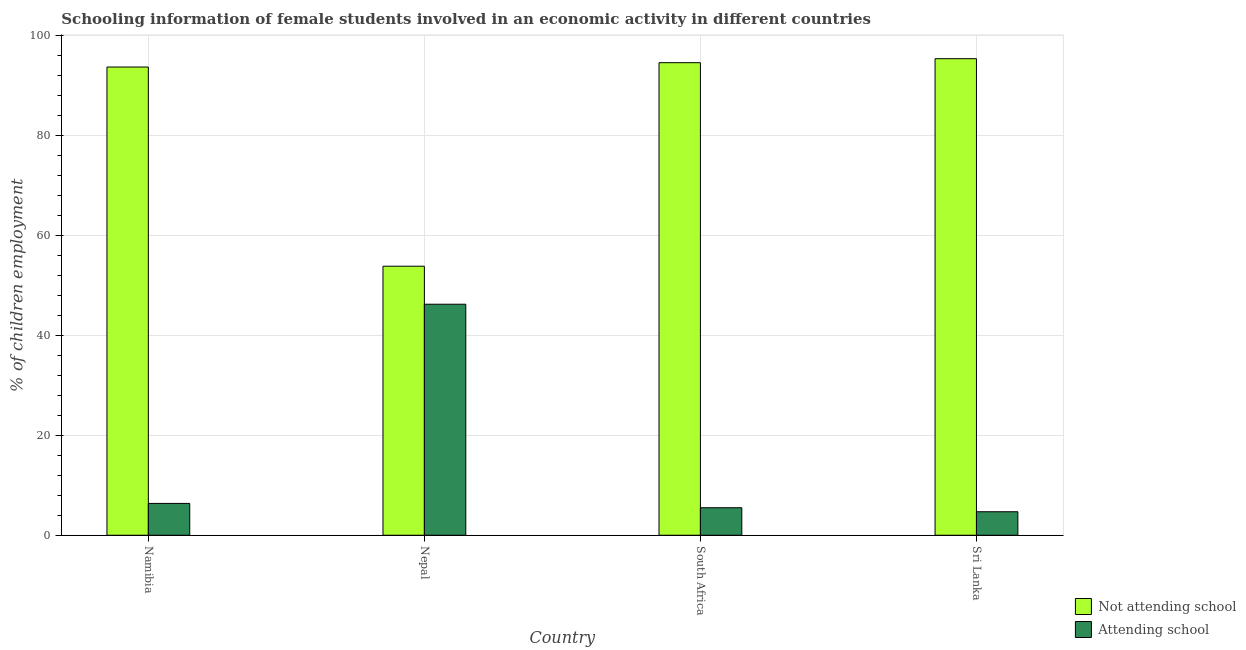How many different coloured bars are there?
Your response must be concise. 2. How many groups of bars are there?
Offer a very short reply. 4. Are the number of bars per tick equal to the number of legend labels?
Give a very brief answer. Yes. Are the number of bars on each tick of the X-axis equal?
Your response must be concise. Yes. How many bars are there on the 4th tick from the left?
Offer a terse response. 2. How many bars are there on the 3rd tick from the right?
Ensure brevity in your answer.  2. What is the label of the 3rd group of bars from the left?
Offer a very short reply. South Africa. What is the percentage of employed females who are attending school in Nepal?
Offer a terse response. 46.2. Across all countries, what is the maximum percentage of employed females who are attending school?
Your response must be concise. 46.2. Across all countries, what is the minimum percentage of employed females who are not attending school?
Your response must be concise. 53.8. In which country was the percentage of employed females who are attending school maximum?
Keep it short and to the point. Nepal. In which country was the percentage of employed females who are attending school minimum?
Provide a short and direct response. Sri Lanka. What is the total percentage of employed females who are attending school in the graph?
Make the answer very short. 62.76. What is the difference between the percentage of employed females who are not attending school in South Africa and that in Sri Lanka?
Make the answer very short. -0.8. What is the difference between the percentage of employed females who are attending school in South Africa and the percentage of employed females who are not attending school in Namibia?
Make the answer very short. -88.14. What is the average percentage of employed females who are not attending school per country?
Your response must be concise. 84.31. What is the difference between the percentage of employed females who are not attending school and percentage of employed females who are attending school in Nepal?
Your answer should be very brief. 7.6. What is the ratio of the percentage of employed females who are attending school in South Africa to that in Sri Lanka?
Provide a succinct answer. 1.17. Is the percentage of employed females who are attending school in Namibia less than that in South Africa?
Give a very brief answer. No. Is the difference between the percentage of employed females who are attending school in Nepal and South Africa greater than the difference between the percentage of employed females who are not attending school in Nepal and South Africa?
Provide a succinct answer. Yes. What is the difference between the highest and the second highest percentage of employed females who are attending school?
Provide a succinct answer. 39.84. What is the difference between the highest and the lowest percentage of employed females who are attending school?
Keep it short and to the point. 41.5. Is the sum of the percentage of employed females who are attending school in South Africa and Sri Lanka greater than the maximum percentage of employed females who are not attending school across all countries?
Ensure brevity in your answer.  No. What does the 2nd bar from the left in Nepal represents?
Make the answer very short. Attending school. What does the 1st bar from the right in South Africa represents?
Make the answer very short. Attending school. Are all the bars in the graph horizontal?
Your answer should be compact. No. How many countries are there in the graph?
Provide a succinct answer. 4. What is the difference between two consecutive major ticks on the Y-axis?
Ensure brevity in your answer.  20. Are the values on the major ticks of Y-axis written in scientific E-notation?
Your answer should be compact. No. Does the graph contain any zero values?
Give a very brief answer. No. Does the graph contain grids?
Make the answer very short. Yes. Where does the legend appear in the graph?
Make the answer very short. Bottom right. What is the title of the graph?
Offer a very short reply. Schooling information of female students involved in an economic activity in different countries. What is the label or title of the Y-axis?
Make the answer very short. % of children employment. What is the % of children employment of Not attending school in Namibia?
Offer a very short reply. 93.64. What is the % of children employment in Attending school in Namibia?
Provide a succinct answer. 6.36. What is the % of children employment of Not attending school in Nepal?
Keep it short and to the point. 53.8. What is the % of children employment of Attending school in Nepal?
Give a very brief answer. 46.2. What is the % of children employment of Not attending school in South Africa?
Ensure brevity in your answer.  94.5. What is the % of children employment of Attending school in South Africa?
Your answer should be compact. 5.5. What is the % of children employment of Not attending school in Sri Lanka?
Offer a terse response. 95.3. What is the % of children employment in Attending school in Sri Lanka?
Your answer should be very brief. 4.7. Across all countries, what is the maximum % of children employment in Not attending school?
Give a very brief answer. 95.3. Across all countries, what is the maximum % of children employment of Attending school?
Offer a very short reply. 46.2. Across all countries, what is the minimum % of children employment in Not attending school?
Provide a succinct answer. 53.8. What is the total % of children employment of Not attending school in the graph?
Offer a very short reply. 337.24. What is the total % of children employment of Attending school in the graph?
Keep it short and to the point. 62.76. What is the difference between the % of children employment in Not attending school in Namibia and that in Nepal?
Your response must be concise. 39.84. What is the difference between the % of children employment of Attending school in Namibia and that in Nepal?
Provide a succinct answer. -39.84. What is the difference between the % of children employment of Not attending school in Namibia and that in South Africa?
Keep it short and to the point. -0.86. What is the difference between the % of children employment in Attending school in Namibia and that in South Africa?
Give a very brief answer. 0.86. What is the difference between the % of children employment of Not attending school in Namibia and that in Sri Lanka?
Offer a terse response. -1.66. What is the difference between the % of children employment in Attending school in Namibia and that in Sri Lanka?
Ensure brevity in your answer.  1.66. What is the difference between the % of children employment of Not attending school in Nepal and that in South Africa?
Provide a short and direct response. -40.7. What is the difference between the % of children employment of Attending school in Nepal and that in South Africa?
Make the answer very short. 40.7. What is the difference between the % of children employment of Not attending school in Nepal and that in Sri Lanka?
Your answer should be very brief. -41.5. What is the difference between the % of children employment of Attending school in Nepal and that in Sri Lanka?
Your answer should be compact. 41.5. What is the difference between the % of children employment in Not attending school in Namibia and the % of children employment in Attending school in Nepal?
Provide a short and direct response. 47.44. What is the difference between the % of children employment in Not attending school in Namibia and the % of children employment in Attending school in South Africa?
Ensure brevity in your answer.  88.14. What is the difference between the % of children employment in Not attending school in Namibia and the % of children employment in Attending school in Sri Lanka?
Keep it short and to the point. 88.94. What is the difference between the % of children employment in Not attending school in Nepal and the % of children employment in Attending school in South Africa?
Offer a very short reply. 48.3. What is the difference between the % of children employment of Not attending school in Nepal and the % of children employment of Attending school in Sri Lanka?
Ensure brevity in your answer.  49.1. What is the difference between the % of children employment of Not attending school in South Africa and the % of children employment of Attending school in Sri Lanka?
Your answer should be compact. 89.8. What is the average % of children employment of Not attending school per country?
Make the answer very short. 84.31. What is the average % of children employment of Attending school per country?
Make the answer very short. 15.69. What is the difference between the % of children employment in Not attending school and % of children employment in Attending school in Namibia?
Provide a succinct answer. 87.27. What is the difference between the % of children employment in Not attending school and % of children employment in Attending school in South Africa?
Your answer should be very brief. 89. What is the difference between the % of children employment of Not attending school and % of children employment of Attending school in Sri Lanka?
Provide a short and direct response. 90.6. What is the ratio of the % of children employment of Not attending school in Namibia to that in Nepal?
Your answer should be compact. 1.74. What is the ratio of the % of children employment of Attending school in Namibia to that in Nepal?
Your answer should be very brief. 0.14. What is the ratio of the % of children employment in Not attending school in Namibia to that in South Africa?
Ensure brevity in your answer.  0.99. What is the ratio of the % of children employment in Attending school in Namibia to that in South Africa?
Make the answer very short. 1.16. What is the ratio of the % of children employment in Not attending school in Namibia to that in Sri Lanka?
Your answer should be compact. 0.98. What is the ratio of the % of children employment in Attending school in Namibia to that in Sri Lanka?
Give a very brief answer. 1.35. What is the ratio of the % of children employment in Not attending school in Nepal to that in South Africa?
Make the answer very short. 0.57. What is the ratio of the % of children employment of Attending school in Nepal to that in South Africa?
Keep it short and to the point. 8.4. What is the ratio of the % of children employment in Not attending school in Nepal to that in Sri Lanka?
Your answer should be compact. 0.56. What is the ratio of the % of children employment of Attending school in Nepal to that in Sri Lanka?
Your answer should be very brief. 9.83. What is the ratio of the % of children employment of Attending school in South Africa to that in Sri Lanka?
Make the answer very short. 1.17. What is the difference between the highest and the second highest % of children employment in Not attending school?
Keep it short and to the point. 0.8. What is the difference between the highest and the second highest % of children employment of Attending school?
Your answer should be compact. 39.84. What is the difference between the highest and the lowest % of children employment of Not attending school?
Ensure brevity in your answer.  41.5. What is the difference between the highest and the lowest % of children employment of Attending school?
Give a very brief answer. 41.5. 